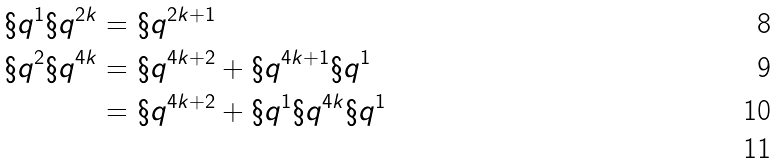<formula> <loc_0><loc_0><loc_500><loc_500>\S q ^ { 1 } \S q ^ { 2 k } & = \S q ^ { 2 k + 1 } \\ \S q ^ { 2 } \S q ^ { 4 k } & = \S q ^ { 4 k + 2 } + \S q ^ { 4 k + 1 } \S q ^ { 1 } \\ & = \S q ^ { 4 k + 2 } + \S q ^ { 1 } \S q ^ { 4 k } \S q ^ { 1 } \\</formula> 